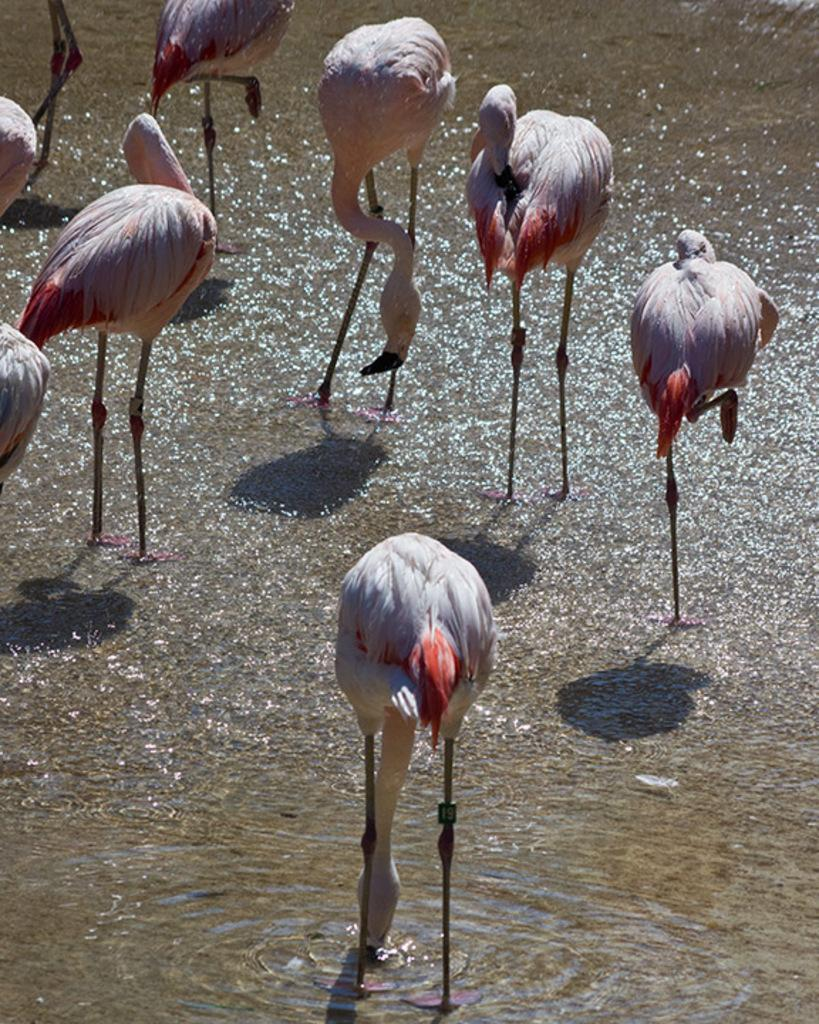What is the main subject of the image? The main subject of the image is many cranes. Where are the cranes located in the image? The cranes are in the center of the image. What can be seen at the bottom of the image? There is water visible at the bottom of the image. What type of jewel is being used to decorate the cranes in the image? There are no jewels present in the image; the cranes are not decorated with any jewels. 